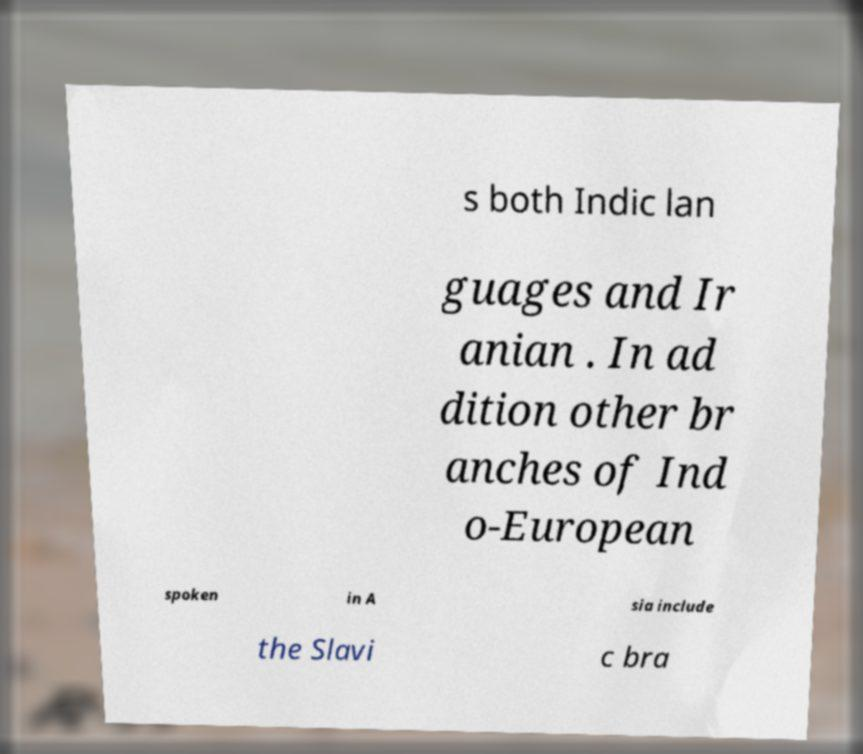What messages or text are displayed in this image? I need them in a readable, typed format. s both Indic lan guages and Ir anian . In ad dition other br anches of Ind o-European spoken in A sia include the Slavi c bra 